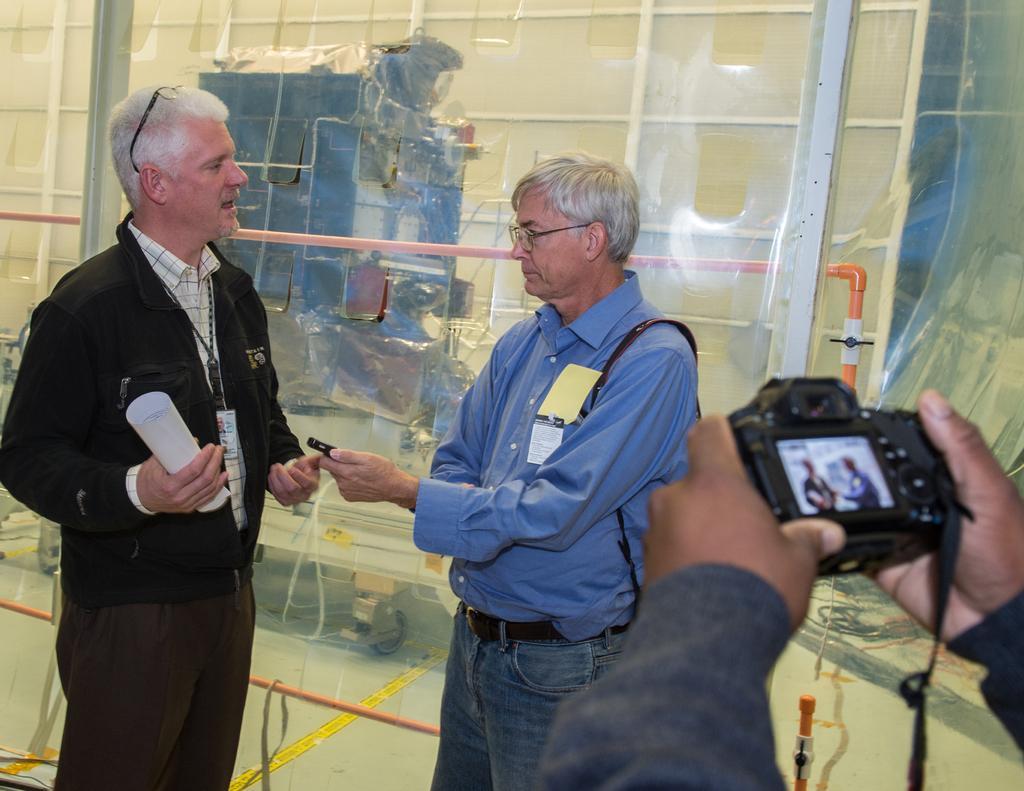Please provide a concise description of this image. In this image there are two persons who are discussing between themselves at the right side of the image there is a person who is taking photograph of those two persons. 